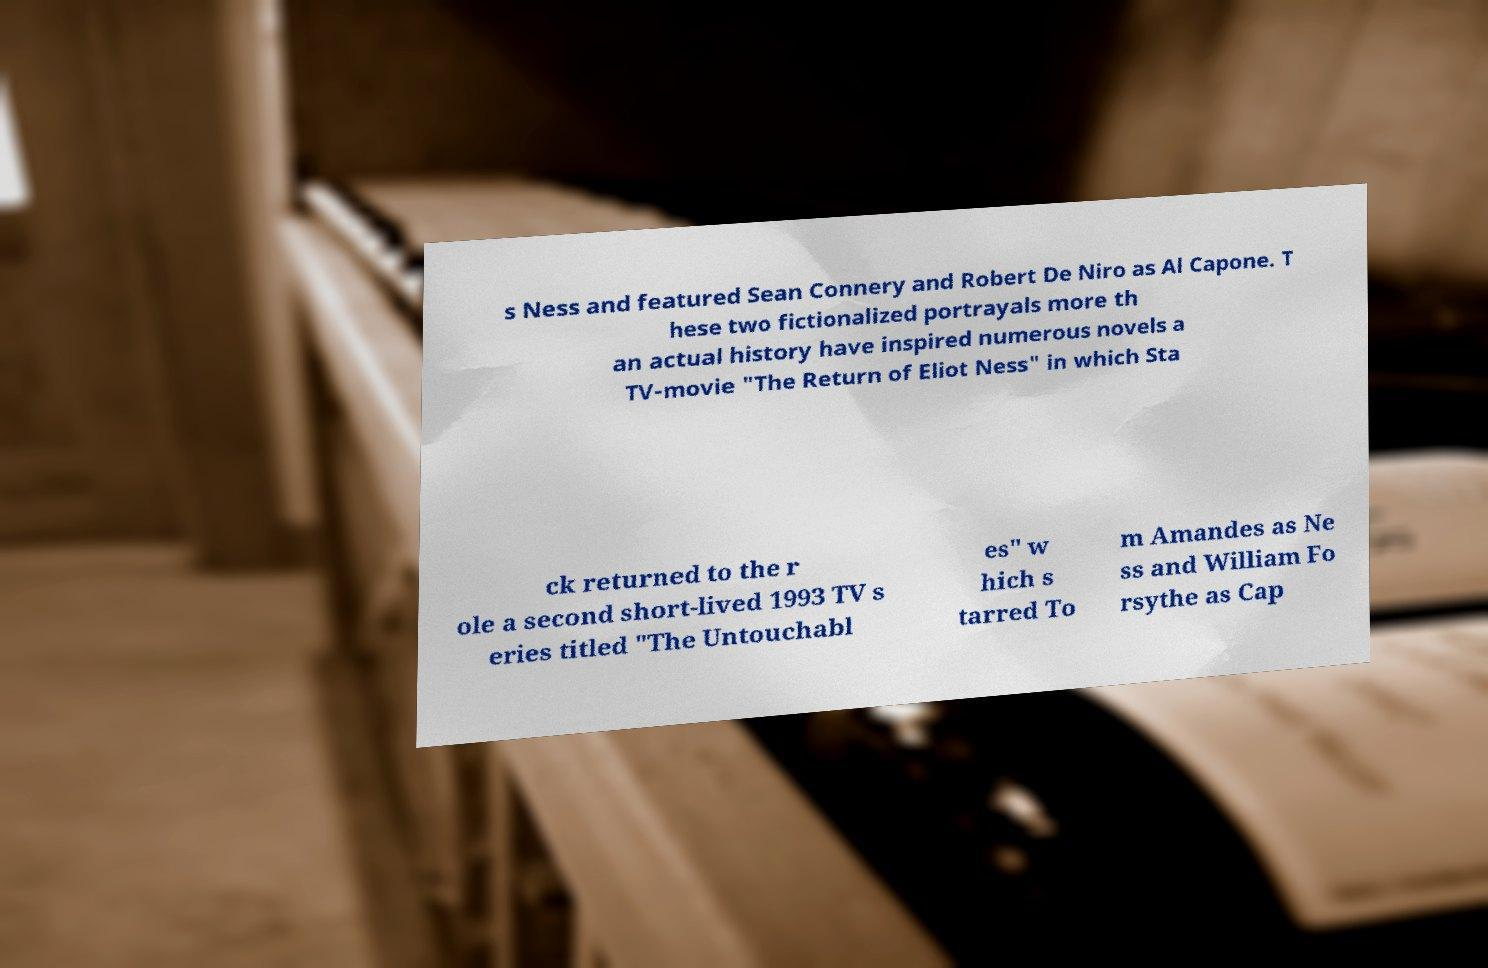Please read and relay the text visible in this image. What does it say? s Ness and featured Sean Connery and Robert De Niro as Al Capone. T hese two fictionalized portrayals more th an actual history have inspired numerous novels a TV-movie "The Return of Eliot Ness" in which Sta ck returned to the r ole a second short-lived 1993 TV s eries titled "The Untouchabl es" w hich s tarred To m Amandes as Ne ss and William Fo rsythe as Cap 